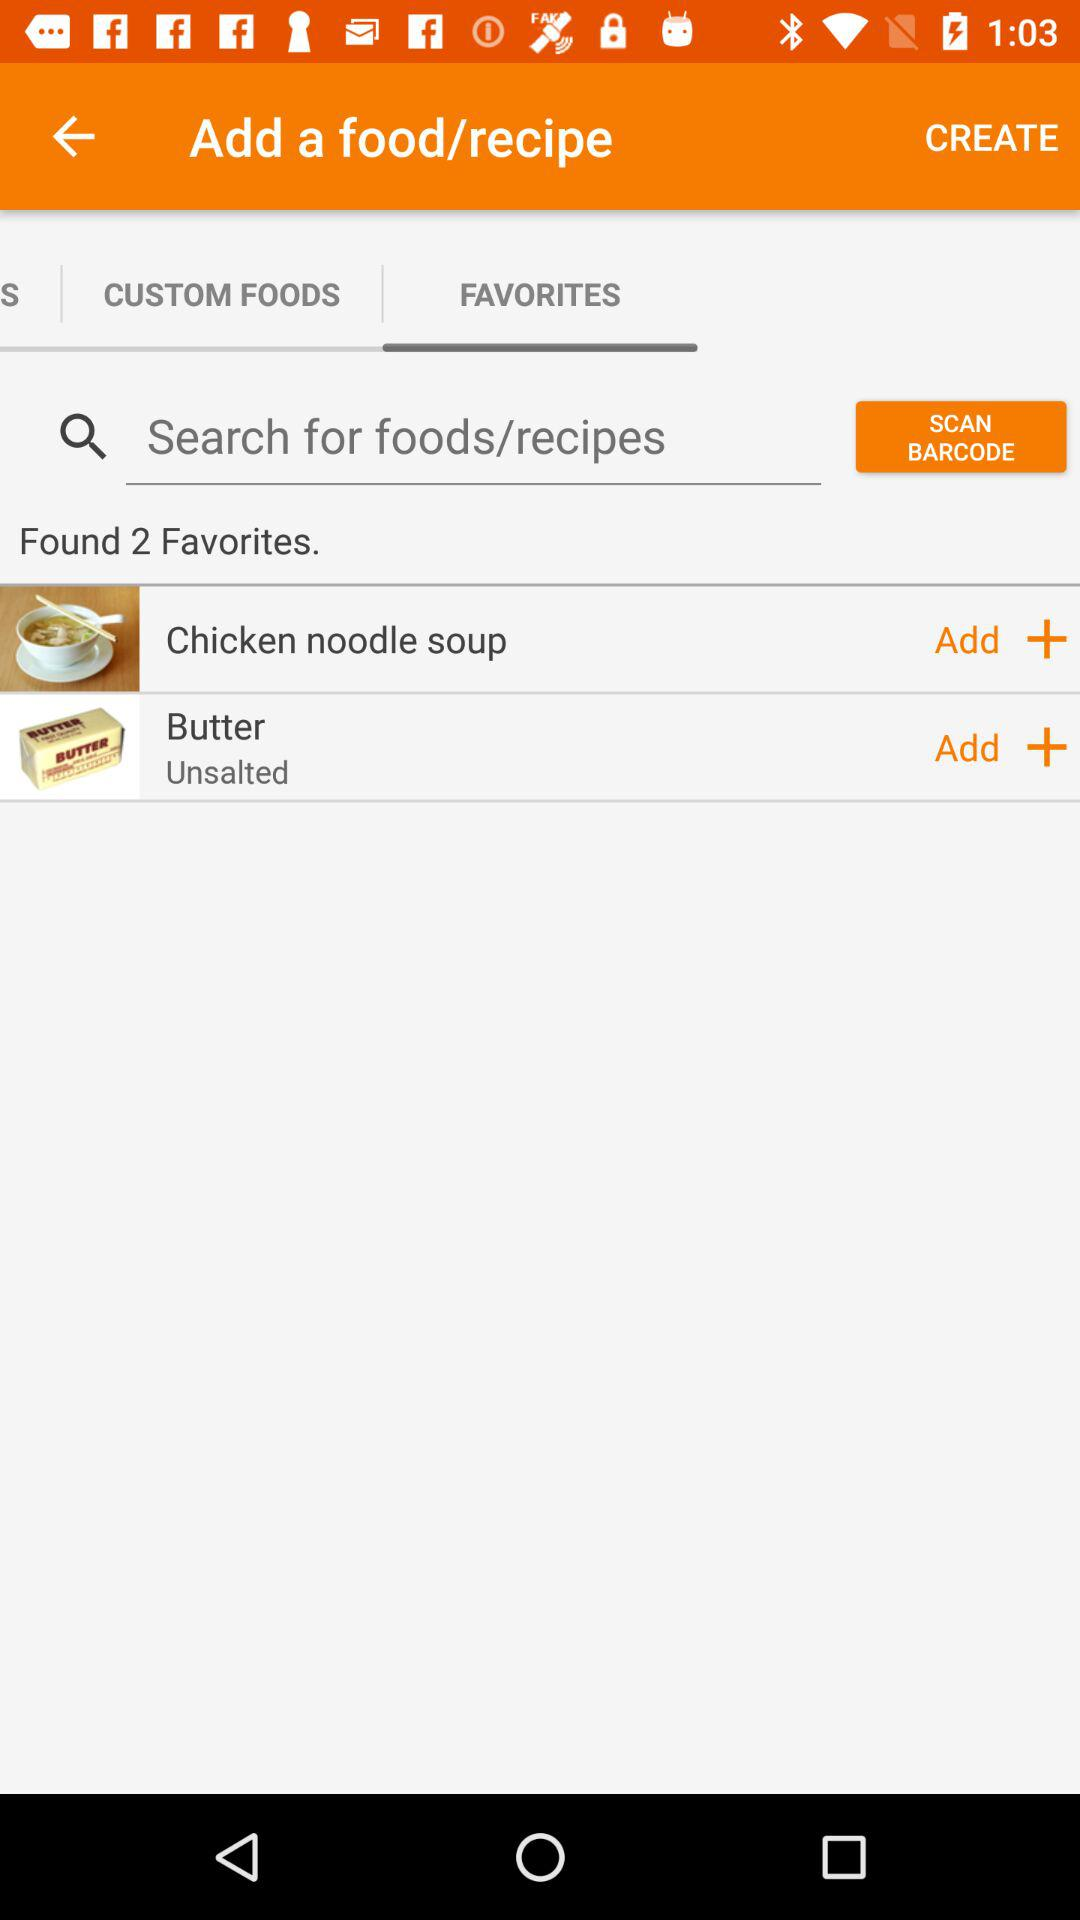Is there any food recipe?
When the provided information is insufficient, respond with <no answer>. <no answer> 